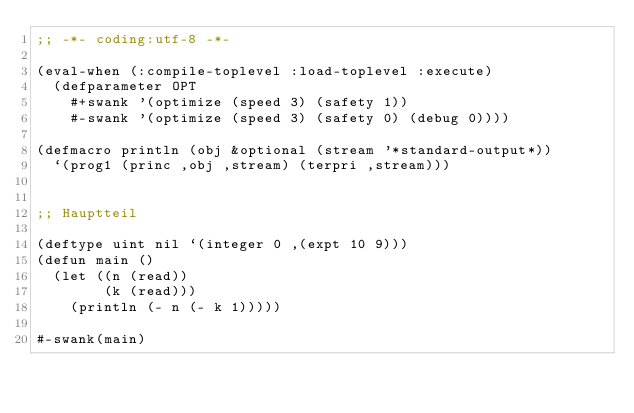Convert code to text. <code><loc_0><loc_0><loc_500><loc_500><_Lisp_>;; -*- coding:utf-8 -*-

(eval-when (:compile-toplevel :load-toplevel :execute)
  (defparameter OPT
    #+swank '(optimize (speed 3) (safety 1))
    #-swank '(optimize (speed 3) (safety 0) (debug 0))))

(defmacro println (obj &optional (stream '*standard-output*))
  `(prog1 (princ ,obj ,stream) (terpri ,stream)))


;; Hauptteil

(deftype uint nil `(integer 0 ,(expt 10 9)))
(defun main ()
  (let ((n (read))
        (k (read)))
    (println (- n (- k 1)))))

#-swank(main)
</code> 